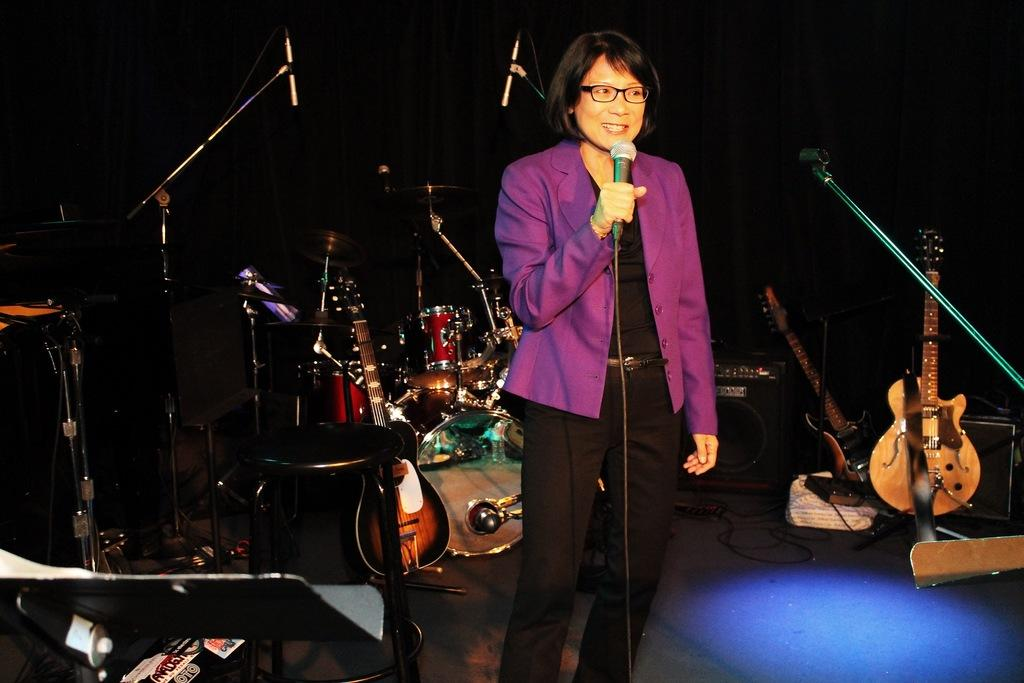What is the woman in the image doing? The woman is standing on stage in the image. What is the woman holding in her hand? The woman is holding a microphone in her hand. What musical instruments are on the left side of the stage? There are drums and guitars on the left side of the stage. How many guitars are on the right side of the stage? There are two guitars on the right side of the stage. Can you see a tiger resting on the stage in the image? No, there is no tiger present in the image. 